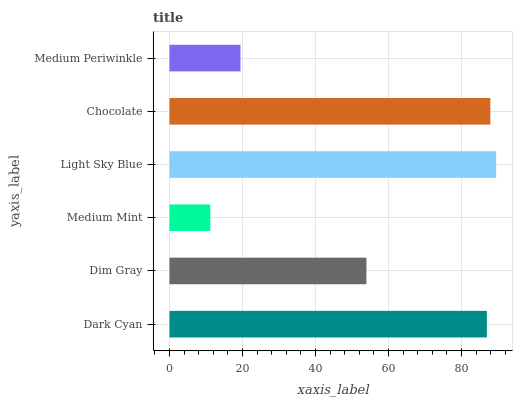Is Medium Mint the minimum?
Answer yes or no. Yes. Is Light Sky Blue the maximum?
Answer yes or no. Yes. Is Dim Gray the minimum?
Answer yes or no. No. Is Dim Gray the maximum?
Answer yes or no. No. Is Dark Cyan greater than Dim Gray?
Answer yes or no. Yes. Is Dim Gray less than Dark Cyan?
Answer yes or no. Yes. Is Dim Gray greater than Dark Cyan?
Answer yes or no. No. Is Dark Cyan less than Dim Gray?
Answer yes or no. No. Is Dark Cyan the high median?
Answer yes or no. Yes. Is Dim Gray the low median?
Answer yes or no. Yes. Is Dim Gray the high median?
Answer yes or no. No. Is Medium Mint the low median?
Answer yes or no. No. 